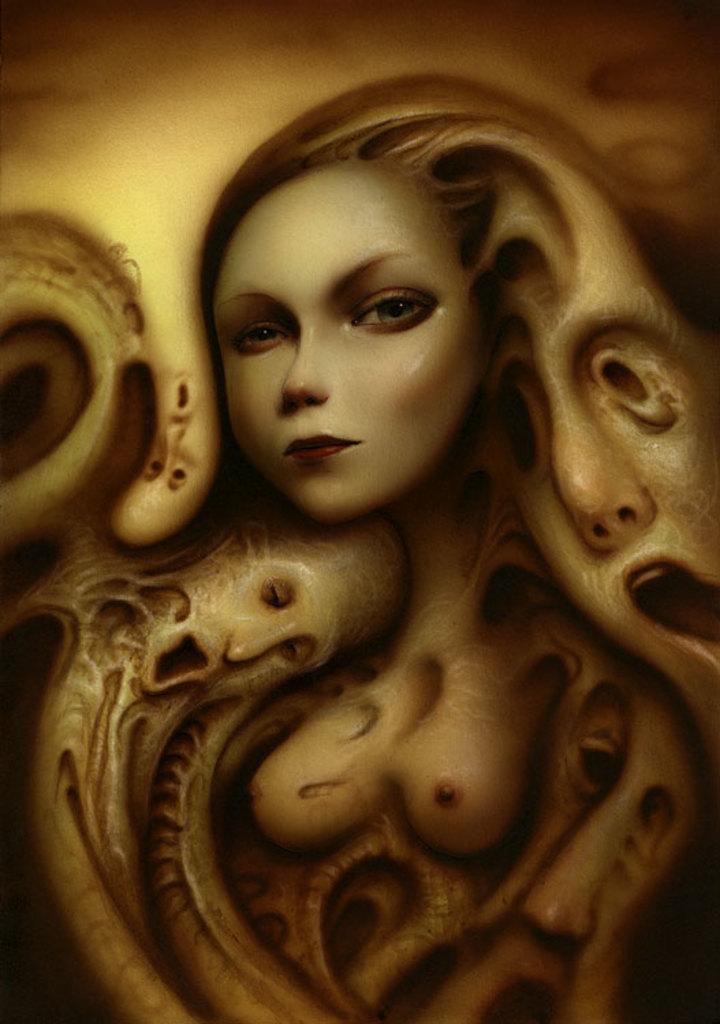How would you summarize this image in a sentence or two? In this picture we can see painting of a woman and faces of people. 